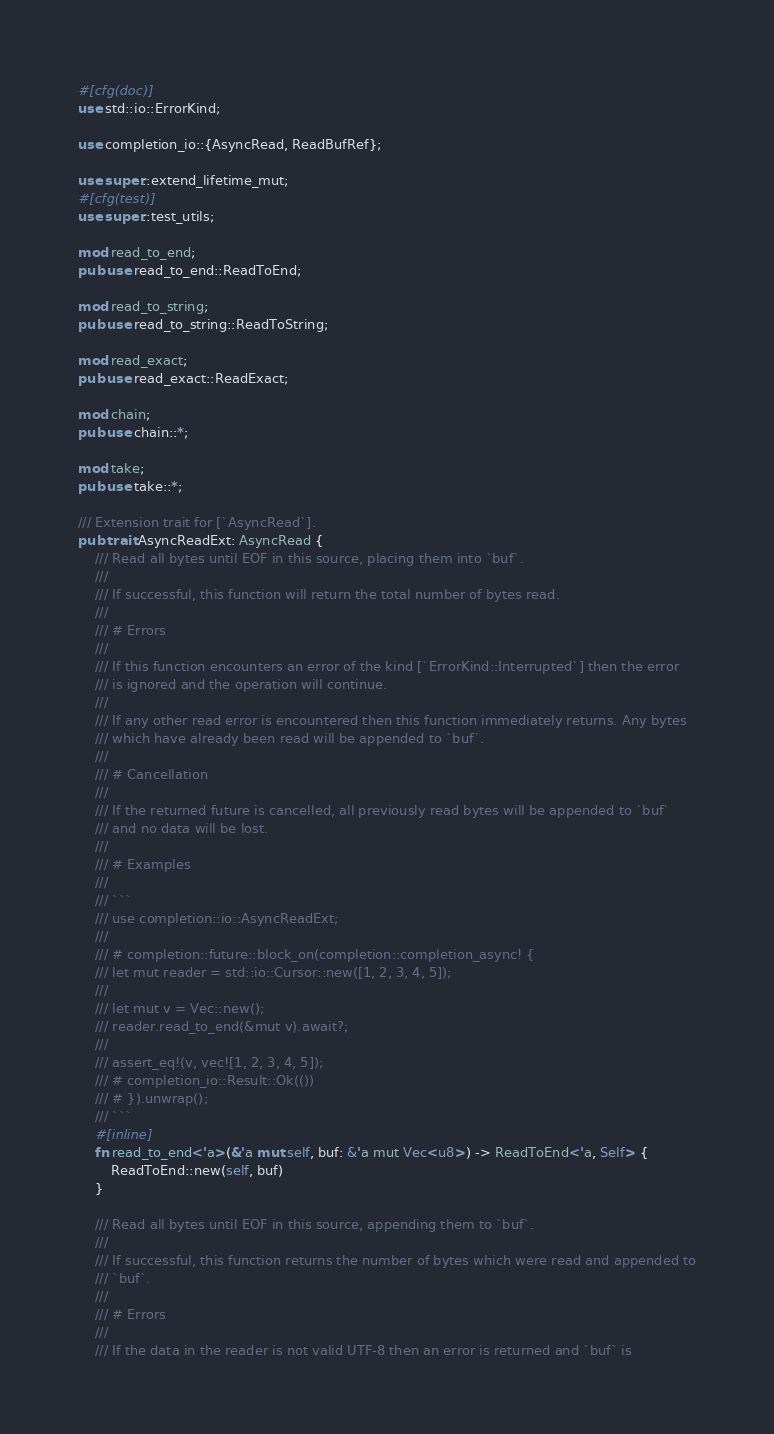<code> <loc_0><loc_0><loc_500><loc_500><_Rust_>#[cfg(doc)]
use std::io::ErrorKind;

use completion_io::{AsyncRead, ReadBufRef};

use super::extend_lifetime_mut;
#[cfg(test)]
use super::test_utils;

mod read_to_end;
pub use read_to_end::ReadToEnd;

mod read_to_string;
pub use read_to_string::ReadToString;

mod read_exact;
pub use read_exact::ReadExact;

mod chain;
pub use chain::*;

mod take;
pub use take::*;

/// Extension trait for [`AsyncRead`].
pub trait AsyncReadExt: AsyncRead {
    /// Read all bytes until EOF in this source, placing them into `buf`.
    ///
    /// If successful, this function will return the total number of bytes read.
    ///
    /// # Errors
    ///
    /// If this function encounters an error of the kind [`ErrorKind::Interrupted`] then the error
    /// is ignored and the operation will continue.
    ///
    /// If any other read error is encountered then this function immediately returns. Any bytes
    /// which have already been read will be appended to `buf`.
    ///
    /// # Cancellation
    ///
    /// If the returned future is cancelled, all previously read bytes will be appended to `buf`
    /// and no data will be lost.
    ///
    /// # Examples
    ///
    /// ```
    /// use completion::io::AsyncReadExt;
    ///
    /// # completion::future::block_on(completion::completion_async! {
    /// let mut reader = std::io::Cursor::new([1, 2, 3, 4, 5]);
    ///
    /// let mut v = Vec::new();
    /// reader.read_to_end(&mut v).await?;
    ///
    /// assert_eq!(v, vec![1, 2, 3, 4, 5]);
    /// # completion_io::Result::Ok(())
    /// # }).unwrap();
    /// ```
    #[inline]
    fn read_to_end<'a>(&'a mut self, buf: &'a mut Vec<u8>) -> ReadToEnd<'a, Self> {
        ReadToEnd::new(self, buf)
    }

    /// Read all bytes until EOF in this source, appending them to `buf`.
    ///
    /// If successful, this function returns the number of bytes which were read and appended to
    /// `buf`.
    ///
    /// # Errors
    ///
    /// If the data in the reader is not valid UTF-8 then an error is returned and `buf` is</code> 